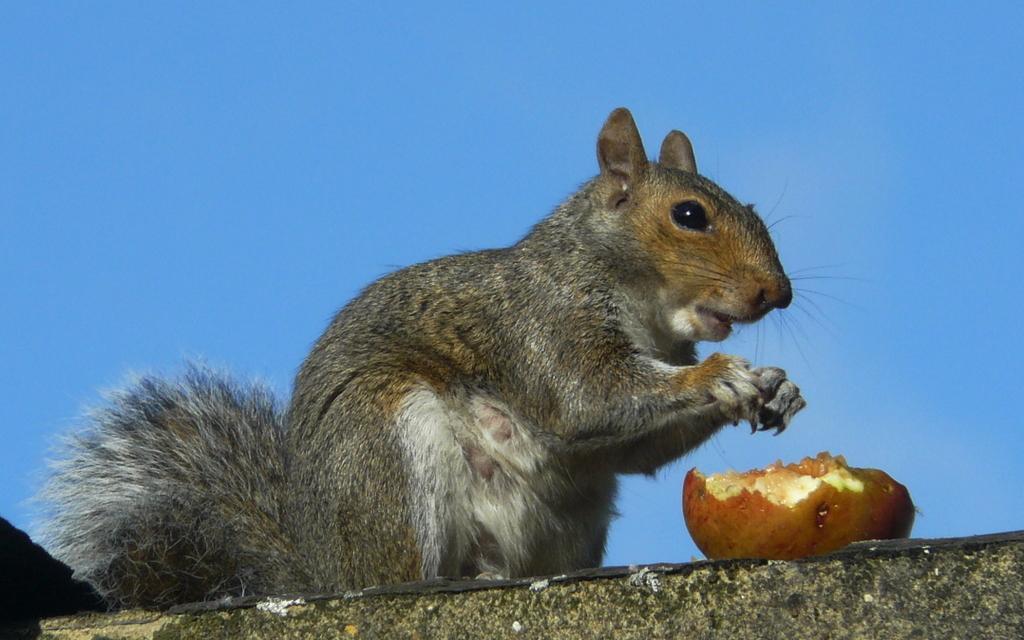Describe this image in one or two sentences. In this image we can see a squirrel on the wall and also a half eaten fruit here. In the background, we can see the blue colour Sky. 